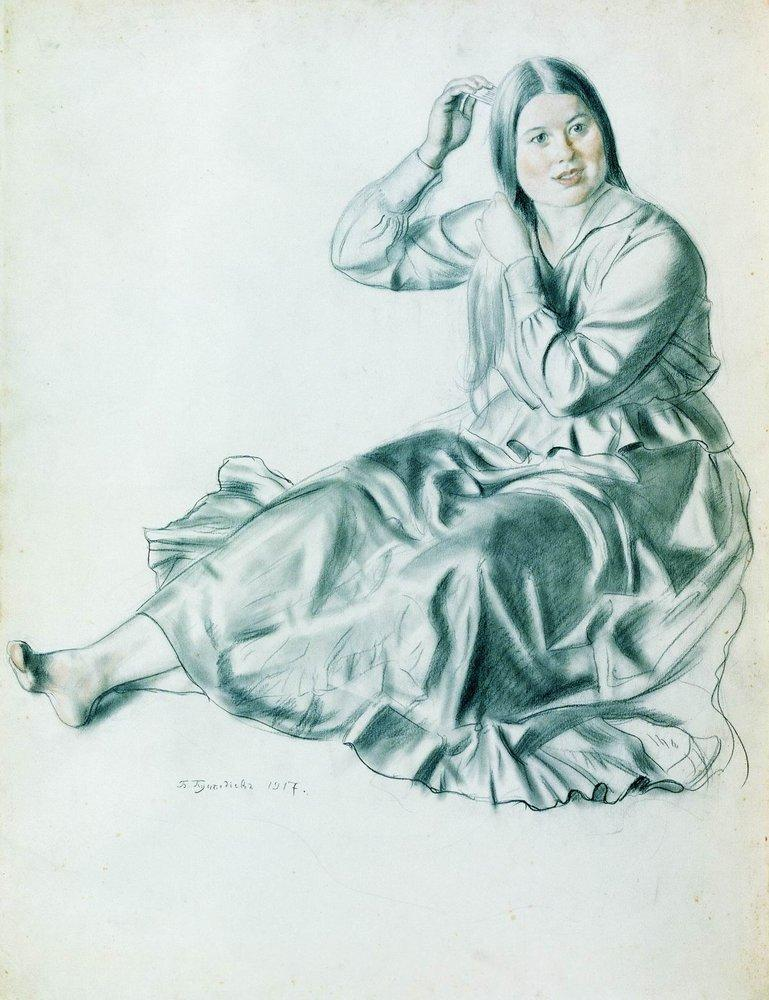Imagine if this sketch were part of a mystical book that tells stories through images. What could be its story? In a mystical book where images tell stories, this sketch could be the tale of a young enchantress, isolating herself from a chaotic world to harness her inner magic. The serene morning routine of combing her hair is a daily ritual that fortifies her spellcraft. Each stroke of the comb through her hair releases a whisper of ancient incantations, protecting her and the ones she loves from distant turmoil. The artist, an arcane chronicler, immortalized her in this moment of serene strength, capturing the calm before she would rise to face the world's challenges with her enchanting abilities. 